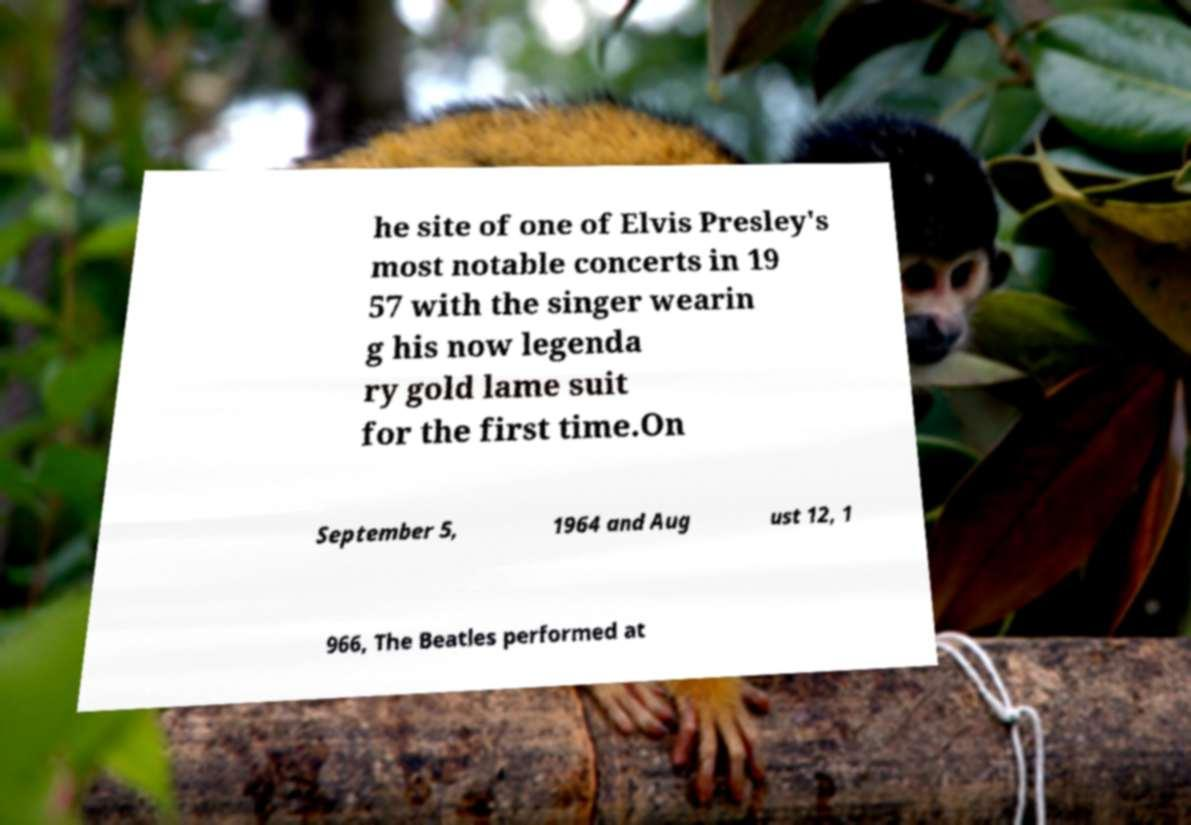I need the written content from this picture converted into text. Can you do that? he site of one of Elvis Presley's most notable concerts in 19 57 with the singer wearin g his now legenda ry gold lame suit for the first time.On September 5, 1964 and Aug ust 12, 1 966, The Beatles performed at 